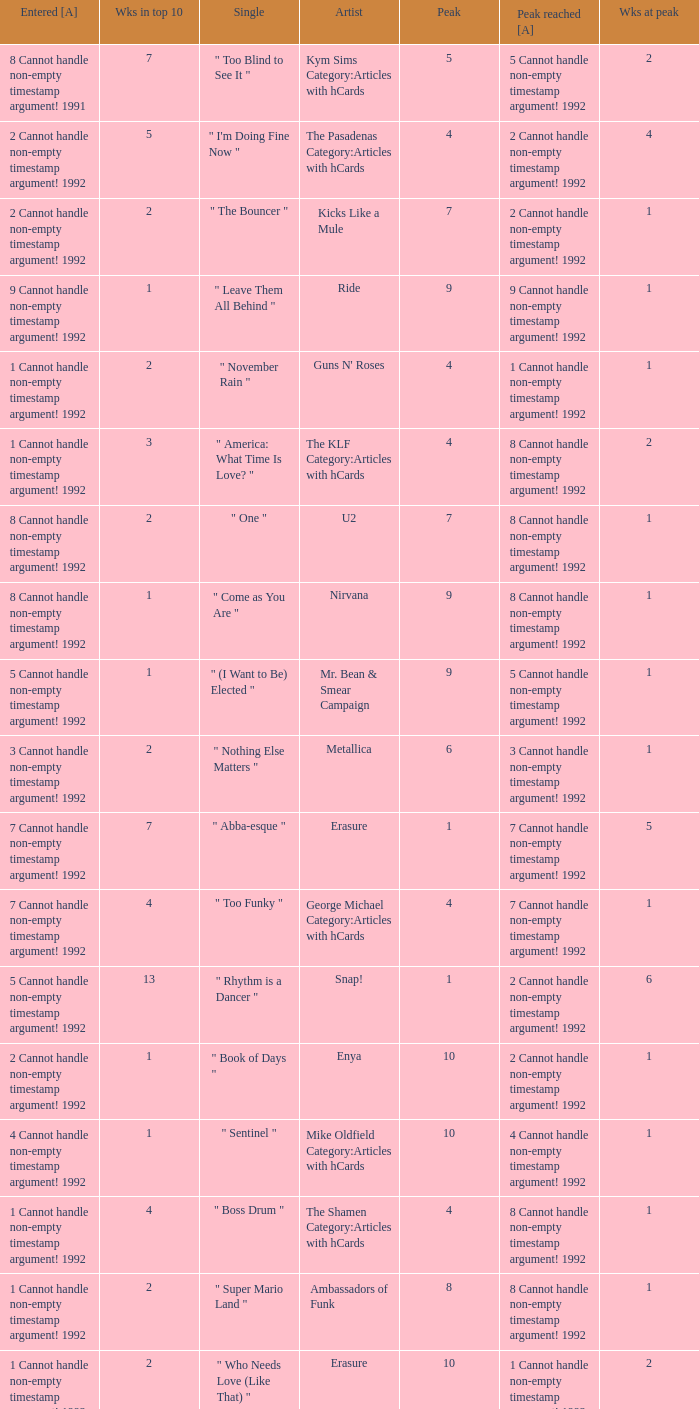What was the peak reached for a single with 4 weeks in the top 10 and entered in 7 cannot handle non-empty timestamp argument! 1992? 7 Cannot handle non-empty timestamp argument! 1992. 